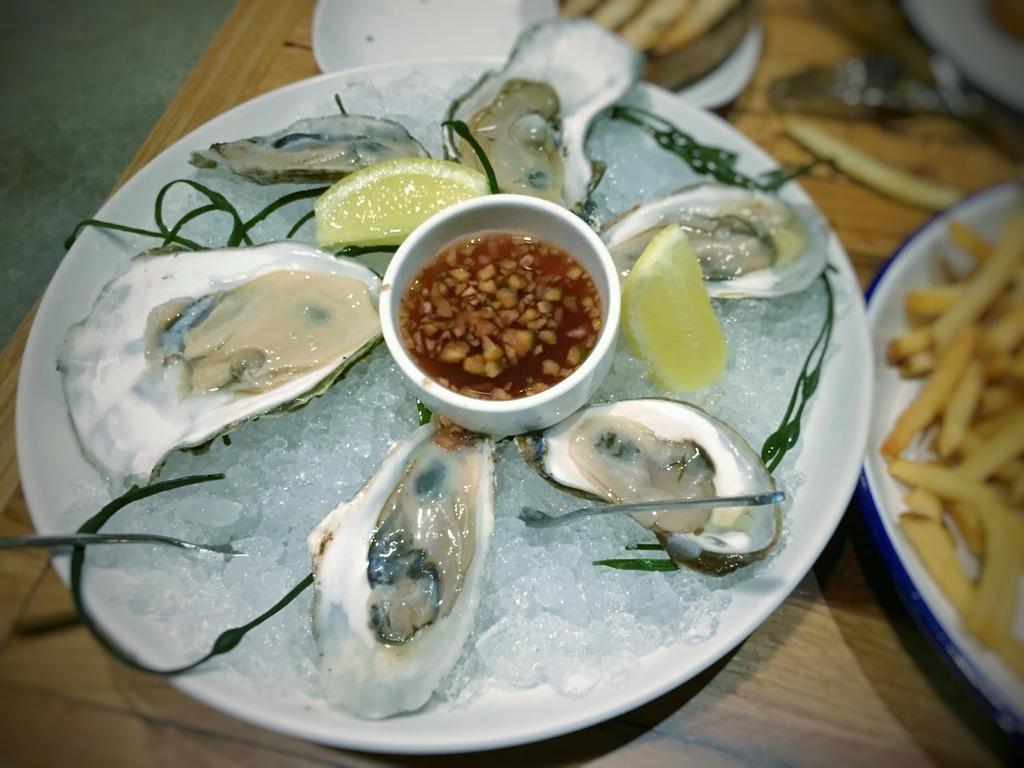How would you summarize this image in a sentence or two? This picture shows food in the plates on the table. we see french fries in one plate and some food in another plate. 